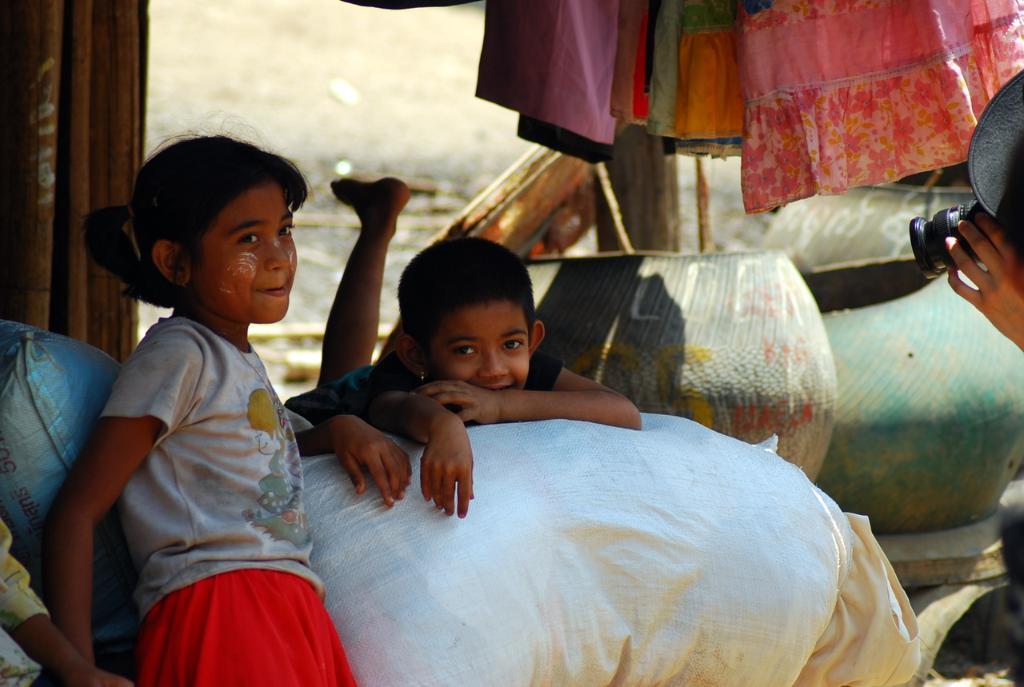Describe this image in one or two sentences. This picture describes about few people, a kid is lying on the bed, and another person is capturing with the help of camera, in the background we can see curtains and pots. 